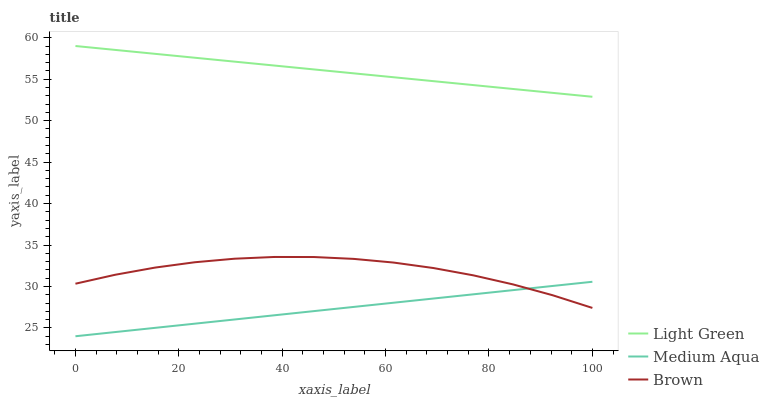Does Light Green have the minimum area under the curve?
Answer yes or no. No. Does Medium Aqua have the maximum area under the curve?
Answer yes or no. No. Is Light Green the smoothest?
Answer yes or no. No. Is Light Green the roughest?
Answer yes or no. No. Does Light Green have the lowest value?
Answer yes or no. No. Does Medium Aqua have the highest value?
Answer yes or no. No. Is Brown less than Light Green?
Answer yes or no. Yes. Is Light Green greater than Medium Aqua?
Answer yes or no. Yes. Does Brown intersect Light Green?
Answer yes or no. No. 